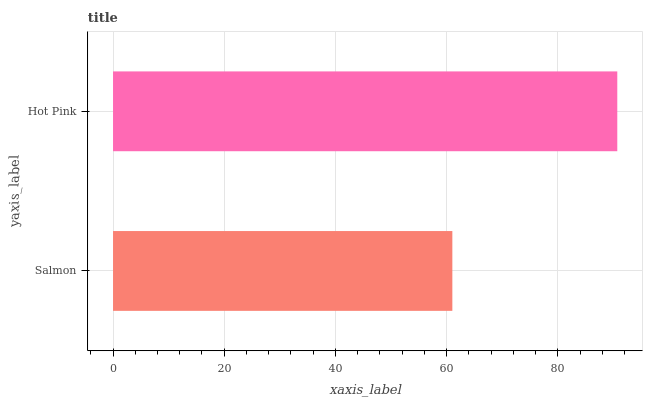Is Salmon the minimum?
Answer yes or no. Yes. Is Hot Pink the maximum?
Answer yes or no. Yes. Is Hot Pink the minimum?
Answer yes or no. No. Is Hot Pink greater than Salmon?
Answer yes or no. Yes. Is Salmon less than Hot Pink?
Answer yes or no. Yes. Is Salmon greater than Hot Pink?
Answer yes or no. No. Is Hot Pink less than Salmon?
Answer yes or no. No. Is Hot Pink the high median?
Answer yes or no. Yes. Is Salmon the low median?
Answer yes or no. Yes. Is Salmon the high median?
Answer yes or no. No. Is Hot Pink the low median?
Answer yes or no. No. 